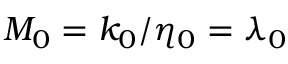Convert formula to latex. <formula><loc_0><loc_0><loc_500><loc_500>M _ { 0 } = k _ { 0 } / \eta _ { 0 } = \lambda _ { 0 }</formula> 